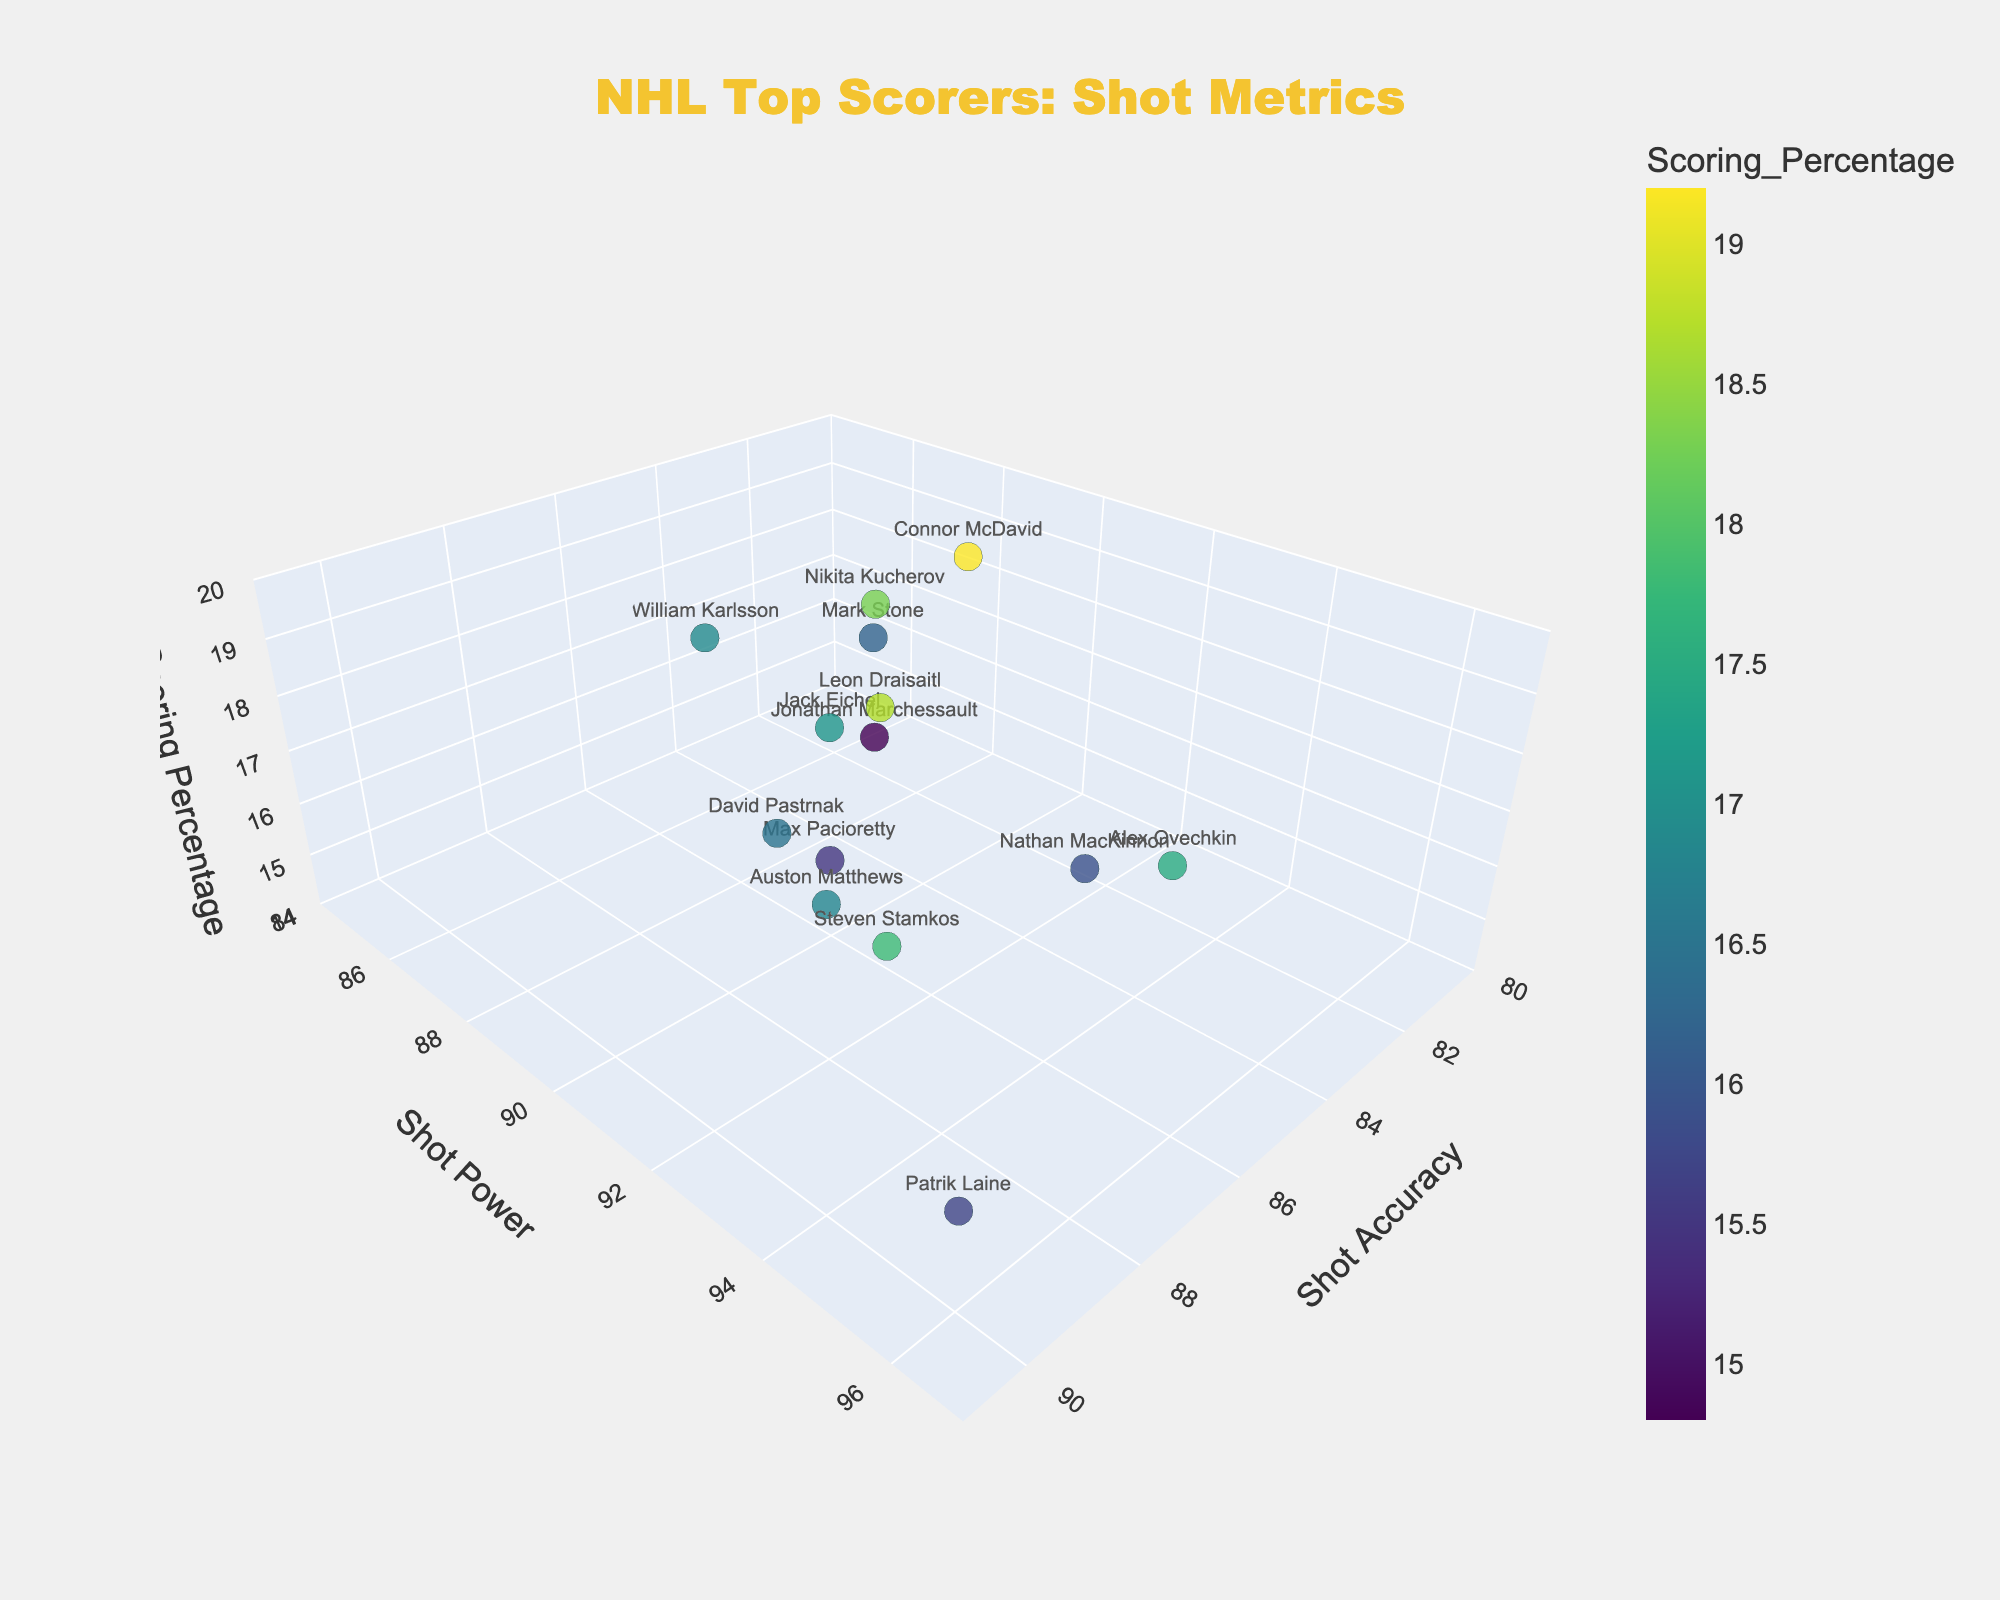What's the title of the 3D scatter plot? The title is at the top center of the plot. From the figure, we see "NHL Top Scorers: Shot Metrics"
Answer: NHL Top Scorers: Shot Metrics What is the range of values on the "Shot Power" axis? The range of the y-axis (Shot Power) can be seen from the axis labels. It ranges from 84 to 97.
Answer: 84 to 97 How many players have a scoring percentage above 18%? Check the z-values (Scoring Percentage) for each player. Players with values above 18% are Connor McDavid, Leon Draisaitl, and Nikita Kucherov.
Answer: 3 players Which player has the highest shot power? Check which player has the highest y-value (Shot Power). Patrik Laine has the highest value at 96.
Answer: Patrik Laine What is the average shot accuracy of the top three players with the highest scoring percentage? Identify the top three players by z-value (Scoring Percentage), which are Connor McDavid, Leon Draisaitl, and Nikita Kucherov, and then calculate the average of their x-values (Shot Accuracy), which are 82, 86, and 83 respectively. Average is (82+86+83)/3 = 83.67
Answer: 83.67 Who has a better shot accuracy, Auston Matthews or Steven Stamkos? Compare the x-values (Shot Accuracy) of Auston Matthews (88) and Steven Stamkos (89). Since 89 > 88, Steven Stamkos has better shot accuracy.
Answer: Steven Stamkos What is the difference in scoring percentage between Alex Ovechkin and Max Pacioretty? Find the z-values (Scoring Percentage) for both players and subtract: Alex Ovechkin (17.5) - Max Pacioretty (15.5) = 2.0
Answer: 2.0 What is the correlation like between shot power and scoring percentage? By observing the distribution of points in the y and z dimensions, a positive trend is apparent where higher shot power seems to correlate with a higher scoring percentage.
Answer: Positive correlation Which player from the Vegas Golden Knights has the highest scoring percentage? Identify the players from the Vegas Golden Knights: Mark Stone, Jonathan Marchessault, William Karlsson. Compare their z-values (Scoring Percentage): Mark Stone (16.2), Jonathan Marchessault (14.8), William Karlsson (16.9), the highest is William Karlsson.
Answer: William Karlsson 